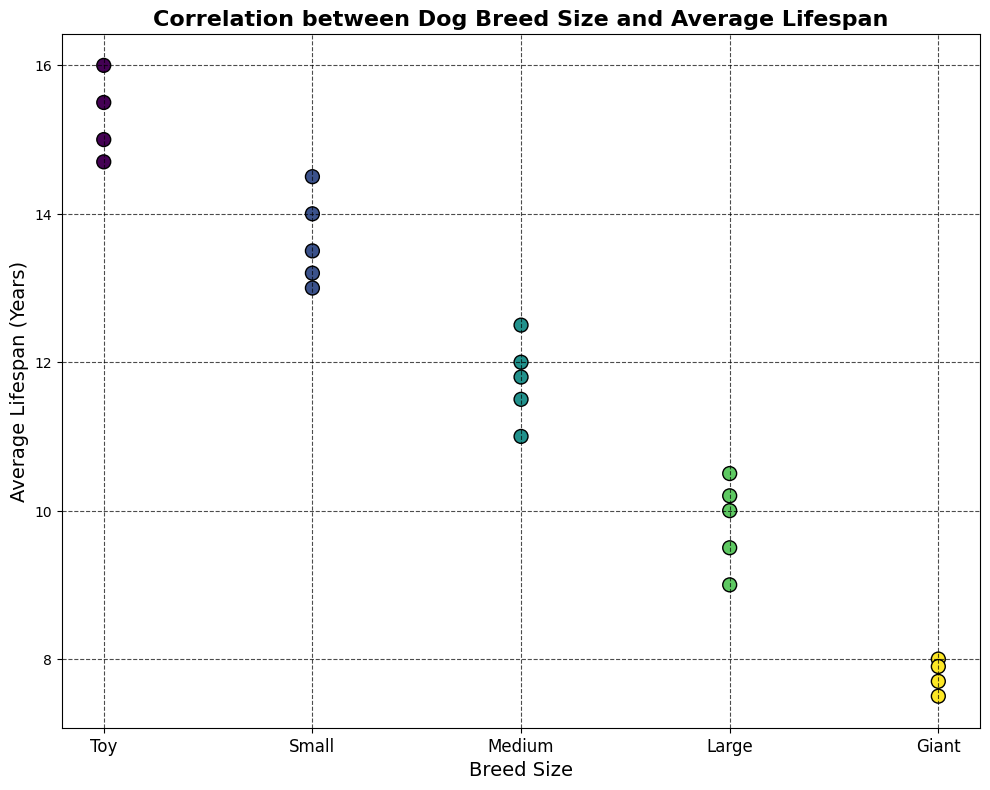Which breed size has the highest average lifespan? The highest point on the y-axis (average lifespan) corresponds to the breed size labeled 'Toy'.
Answer: Toy Which breed size has the lowest average lifespan? The lowest point on the y-axis (average lifespan) corresponds to the breed size labeled 'Giant'.
Answer: Giant What is the average lifespan of Medium-sized breeds based on the given data points? The average lifespan of Medium-sized breeds can be computed by averaging their given lifespans: (12 + 11 + 11.5 + 12.5 + 11.8) / 5 = 11.76 years.
Answer: 11.76 years How many unique breed sizes are represented in the plot? By examining the x-axis labels, we can see there are five unique breed sizes: 'Toy', 'Small', 'Medium', 'Large', and 'Giant'.
Answer: 5 How does the average lifespan of Toy breeds compare to that of Large breeds? The average lifespans of Toy breeds are significantly higher than those of Large breeds. Toy breeds range from 14.7 to 16 years, whereas Large breeds range from 9.5 to 10.5 years.
Answer: Toy breeds have a higher average lifespan than Large breeds What visual feature indicates the different breed sizes on the scatter plot? The different breed sizes are indicated by the various positions (x-axis values) and colors used in the scatter plot points.
Answer: Positions and colors What is the range of lifespans for Giant-sized breeds? The lifespans for Giant-sized breeds range from 7.5 to 8 years based on the plotted points.
Answer: 7.5 to 8 years Are there any breed sizes that have overlapping average lifespans? If so, which ones? Both 'Small' and 'Medium' breed sizes have an average lifespan data point at 11.5 years, indicating an overlap.
Answer: Small and Medium What trend is observed in the correlation between breed size and average lifespan? The trend observed is that as the breed size increases (from Toy to Giant), the average lifespan tends to decrease.
Answer: Larger breeds tend to have shorter lifespans Which breed sizes have their average lifespan most closely clustered? The breed sizes 'Large' and 'Giant' have their average lifespan most closely clustered, with points close to each other.
Answer: Large and Giant 